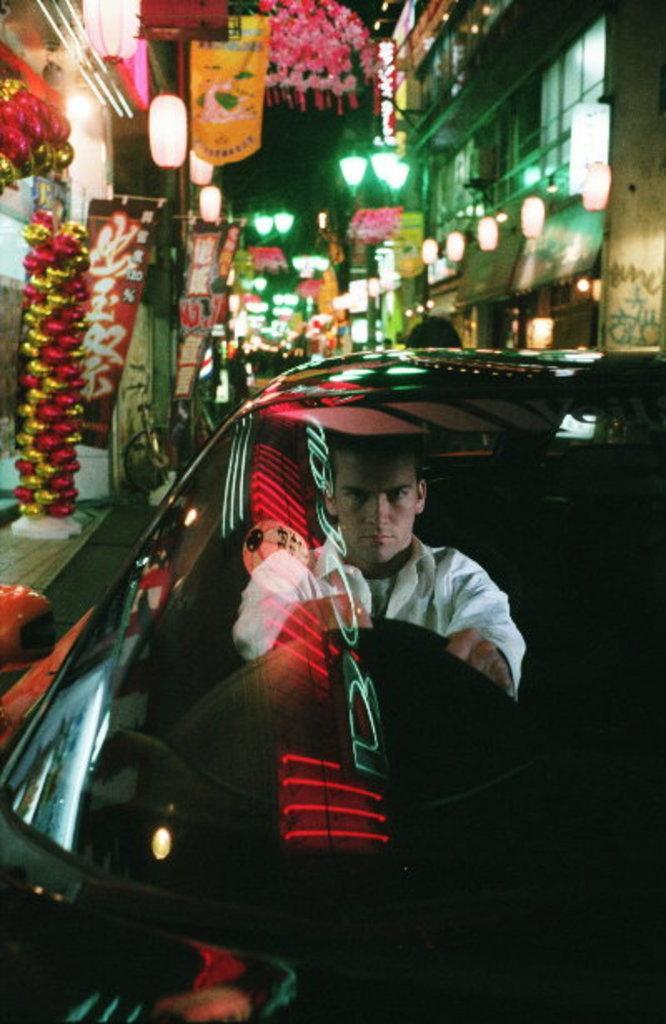Please provide a concise description of this image. In Front portion of the picture we can see a man riding a car. On the background we can see decorative flowers, buildings and lights. 